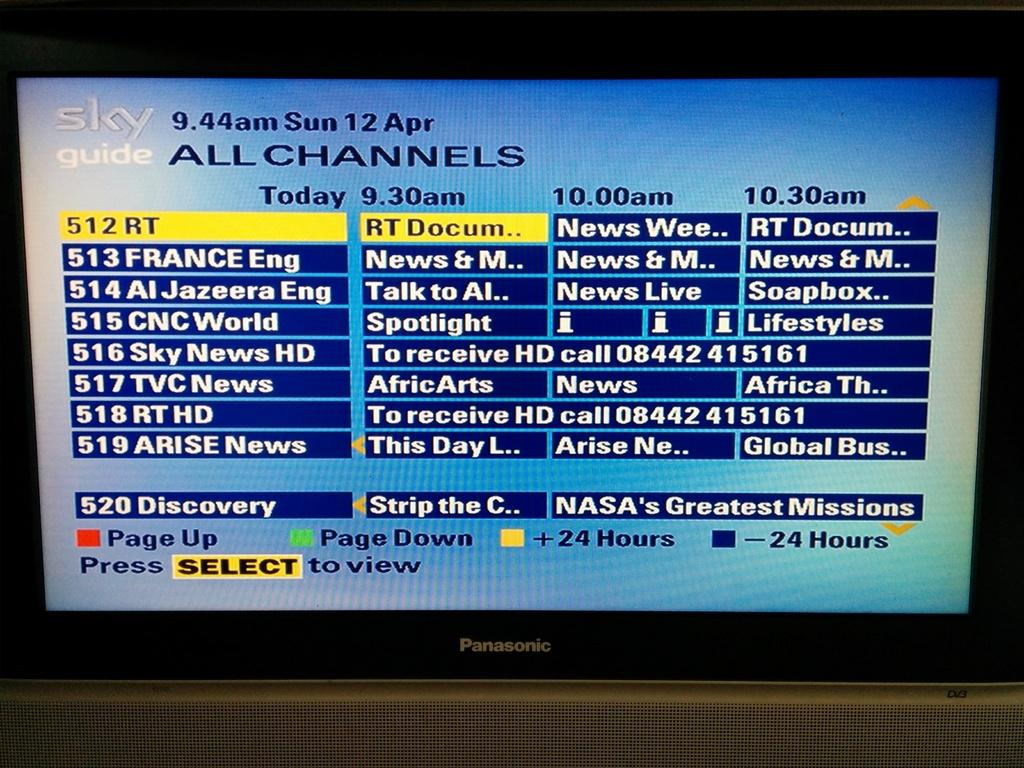<image>
Relay a brief, clear account of the picture shown. A Panasonic Tv is open to a channel called Sky guide. 